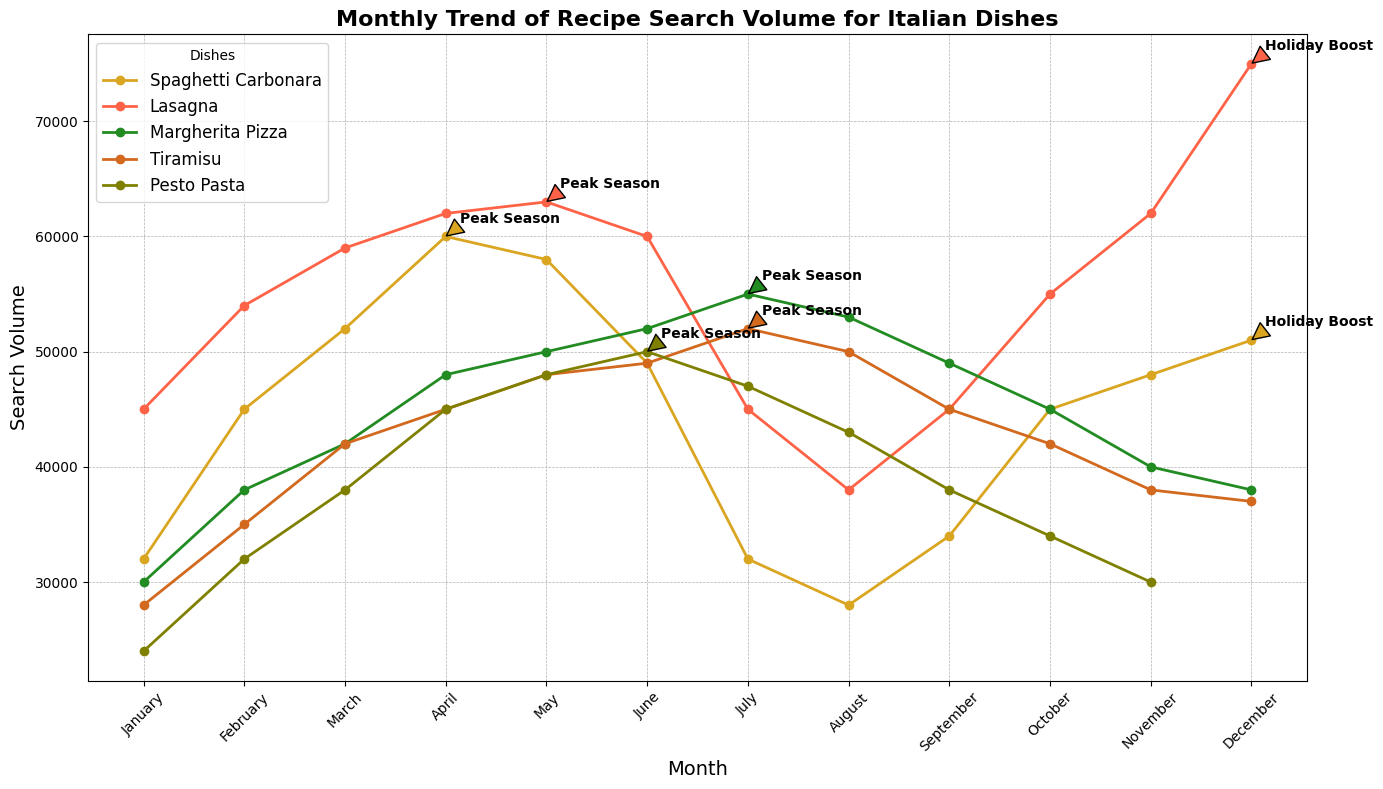What's the peak search volume for Spaghetti Carbonara? The peak search volume for Spaghetti Carbonara happens in April, as indicated by the "Peak Season" annotation. According to the plot, the search volume in April is the highest compared to other months.
Answer: 60,000 Which dish has the highest search volume in December? To determine the dish with the highest search volume in December, look at the data points for all dishes in December. The dish with the maximum value in this month is Lasagna, as indicated by the "Holiday Boost" annotation.
Answer: Lasagna Among all the dishes, which one has the lowest search volume in January? By observing the January search volume values for the dishes: Spaghetti Carbonara (32,000), Lasagna (45,000), Margherita Pizza (30,000), Tiramisu (28,000), and Pesto Pasta (24,000), it can be seen that Pesto Pasta has the lowest search volume.
Answer: Pesto Pasta When is Margherita Pizza's peak season, and what is the search volume during that time? The peak season for Margherita Pizza is annotated in the chart during July. The search volume for Margherita Pizza in this month is visually the highest at 55,000.
Answer: July, 55,000 How does the search volume for Tiramisu change from June to July? By looking at the plot, the search volume for Tiramisu increases from June to July. In June, the volume is 49,000, and in July, it peaks at 52,000, suggesting a positive change of 3,000.
Answer: It increases by 3,000 What is the search volume trend for Lasagna from September to December? From the plot, the search volume for Lasagna presents an upward trend from September to December. Specifically, the values increase gradually from 45,000 in September, to 55,000 in October, to 62,000 in November, and peaking at 75,000 in December with the "Holiday Boost" annotation.
Answer: Increasing trend Which two dishes have the closest search volumes in May? By comparing the search volumes for May: Spaghetti Carbonara (58,000), Lasagna (63,000), Margherita Pizza (50,000), Tiramisu (48,000), and Pesto Pasta (48,000), it’s clear that Tiramisu and Pesto Pasta, both at 48,000, have the closest volumes.
Answer: Tiramisu and Pesto Pasta How does the search volume of Pesto Pasta in June compare to that in April? The search volume for Pesto Pasta is observed to increase from April (45,000) to its peak season in June (50,000). Therefore, it rises by 5,000.
Answer: It increases For which month does the search volume for both Margherita Pizza and Tiramisu reach their peak? From the annotations in the plot, both Margherita Pizza and Tiramisu have their peak search volumes annotated in July, both marked as "Peak Season".
Answer: July 